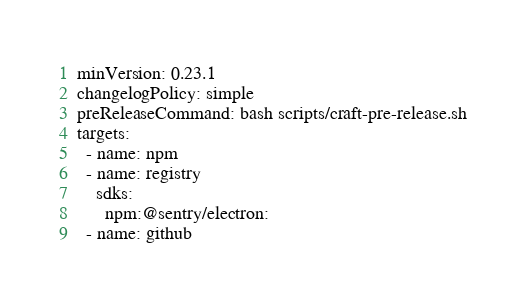Convert code to text. <code><loc_0><loc_0><loc_500><loc_500><_YAML_>minVersion: 0.23.1
changelogPolicy: simple
preReleaseCommand: bash scripts/craft-pre-release.sh
targets:
  - name: npm
  - name: registry
    sdks:
      npm:@sentry/electron:
  - name: github
</code> 